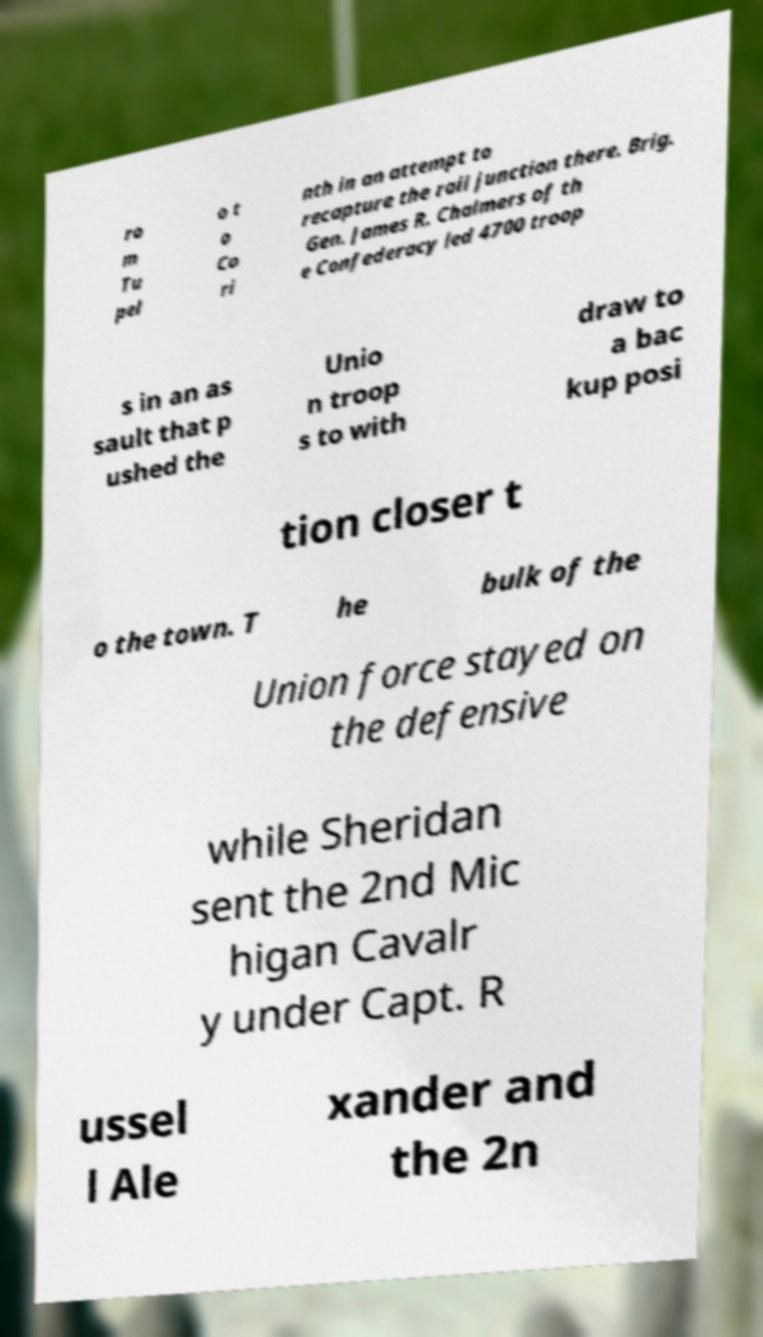I need the written content from this picture converted into text. Can you do that? ro m Tu pel o t o Co ri nth in an attempt to recapture the rail junction there. Brig. Gen. James R. Chalmers of th e Confederacy led 4700 troop s in an as sault that p ushed the Unio n troop s to with draw to a bac kup posi tion closer t o the town. T he bulk of the Union force stayed on the defensive while Sheridan sent the 2nd Mic higan Cavalr y under Capt. R ussel l Ale xander and the 2n 